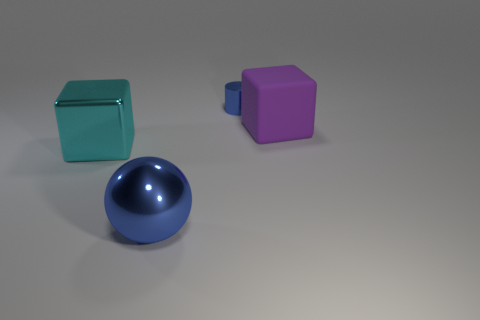Add 1 cylinders. How many objects exist? 5 Subtract all cyan blocks. How many blocks are left? 1 Subtract all cylinders. How many objects are left? 3 Subtract 1 blocks. How many blocks are left? 1 Add 3 blue cylinders. How many blue cylinders exist? 4 Subtract 0 green blocks. How many objects are left? 4 Subtract all green cylinders. Subtract all red balls. How many cylinders are left? 1 Subtract all purple balls. How many green cubes are left? 0 Subtract all big blocks. Subtract all blue shiny balls. How many objects are left? 1 Add 1 purple things. How many purple things are left? 2 